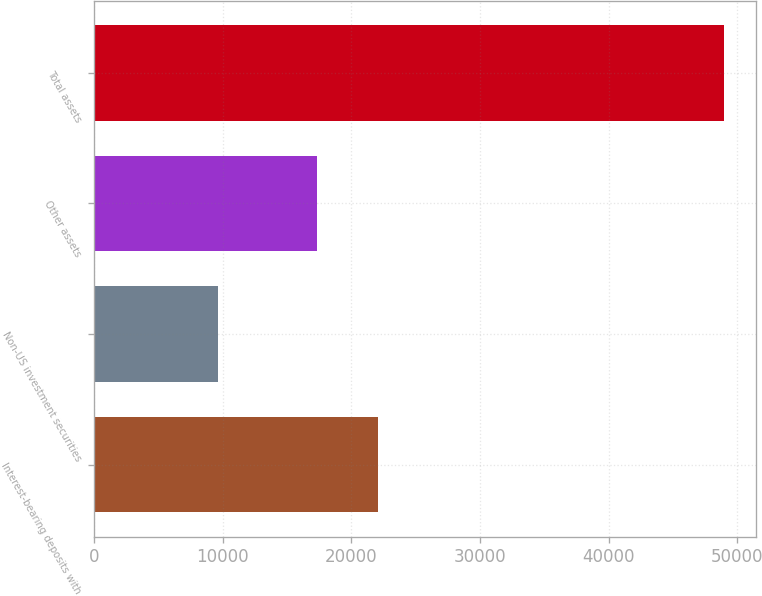<chart> <loc_0><loc_0><loc_500><loc_500><bar_chart><fcel>Interest-bearing deposits with<fcel>Non-US investment securities<fcel>Other assets<fcel>Total assets<nl><fcel>22086<fcel>9611<fcel>17316<fcel>49013<nl></chart> 